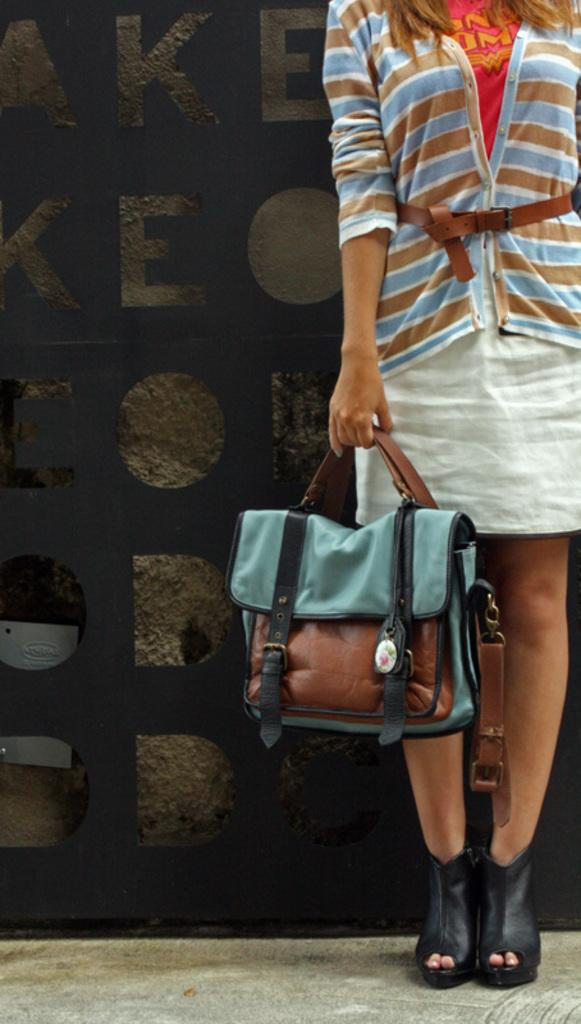What is the woman in the image doing? The woman is standing in the image. What is the woman carrying in the image? The woman is carrying a handbag. What type of clothing is the woman wearing in the image? The woman is wearing a jacket and a belt. What type of footwear is the woman wearing in the image? The woman is wearing shoes. What can be seen on the wall in the background of the image? There is text on the wall in the background. What degree does the woman have in the image? There is no indication of the woman's educational background or degree in the image. What type of road can be seen in the image? There is no road visible in the image. 